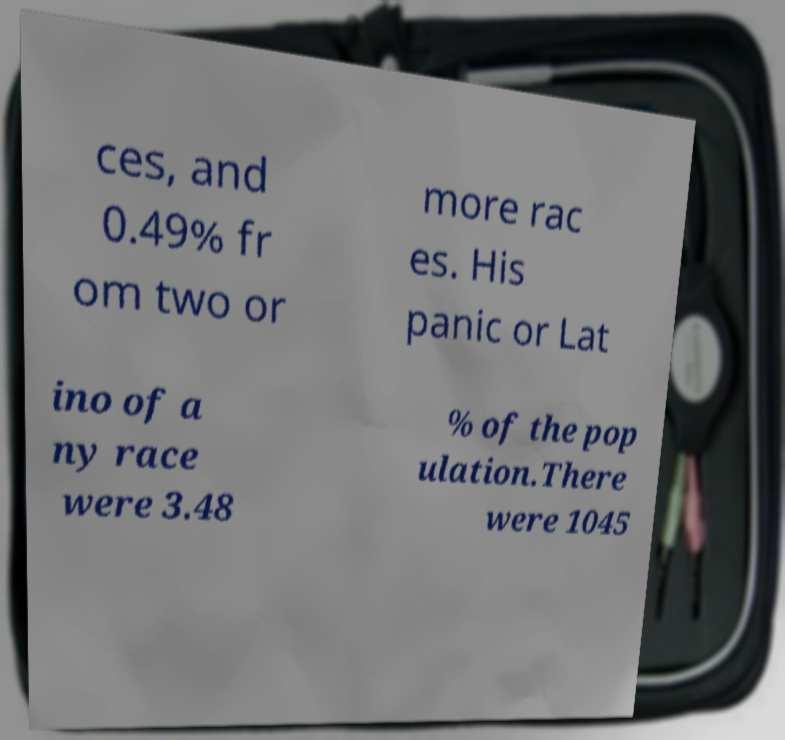Can you read and provide the text displayed in the image?This photo seems to have some interesting text. Can you extract and type it out for me? ces, and 0.49% fr om two or more rac es. His panic or Lat ino of a ny race were 3.48 % of the pop ulation.There were 1045 